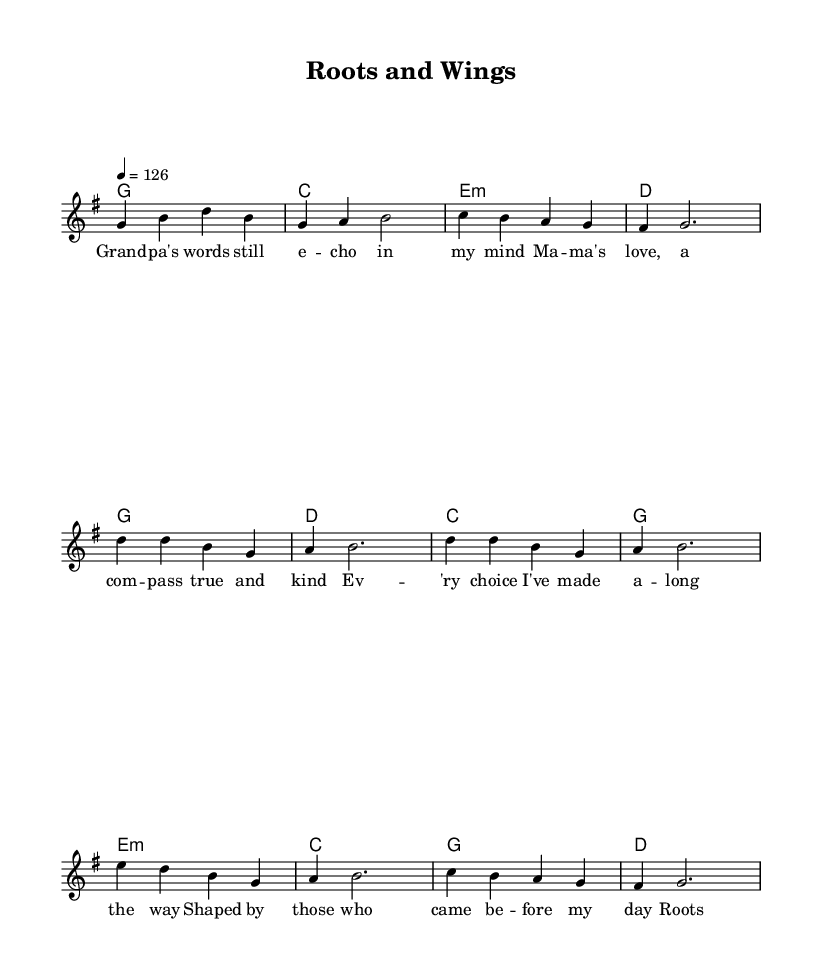What is the key signature of this music? The key signature has one sharp which indicates G major.
Answer: G major What is the time signature of this piece? The time signature is indicated by the 4/4 at the beginning of the music, meaning there are four beats in each measure.
Answer: 4/4 What is the tempo marking for this music? The tempo marking is indicated by "4 = 126" which means there are 126 beats per minute.
Answer: 126 How many sections does this song have? The song contains three sections labeled as Verse, Chorus, and Bridge.
Answer: Three In which section does the phrase "Roots and wings, that's what they gave to me" appear? This phrase is located in the Chorus section as indicated by the lyrics below the melody.
Answer: Chorus What emotional theme is conveyed in the lyrics of the song? The lyrics talk about generational wisdom and family influences, expressing gratitude for the lessons learned from ancestors.
Answer: Generational wisdom How does the harmony change between the Verse and the Chorus? In the Verse, the chords progress from G to C to E minor to D, while in the Chorus, it changes to G, D, C, and then back to G. This reflects a lift in the musical phrase.
Answer: G to C to E minor to D; G to D to C to G 